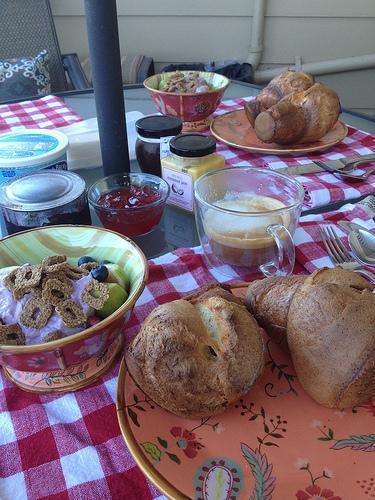How many plates are there?
Give a very brief answer. 2. 